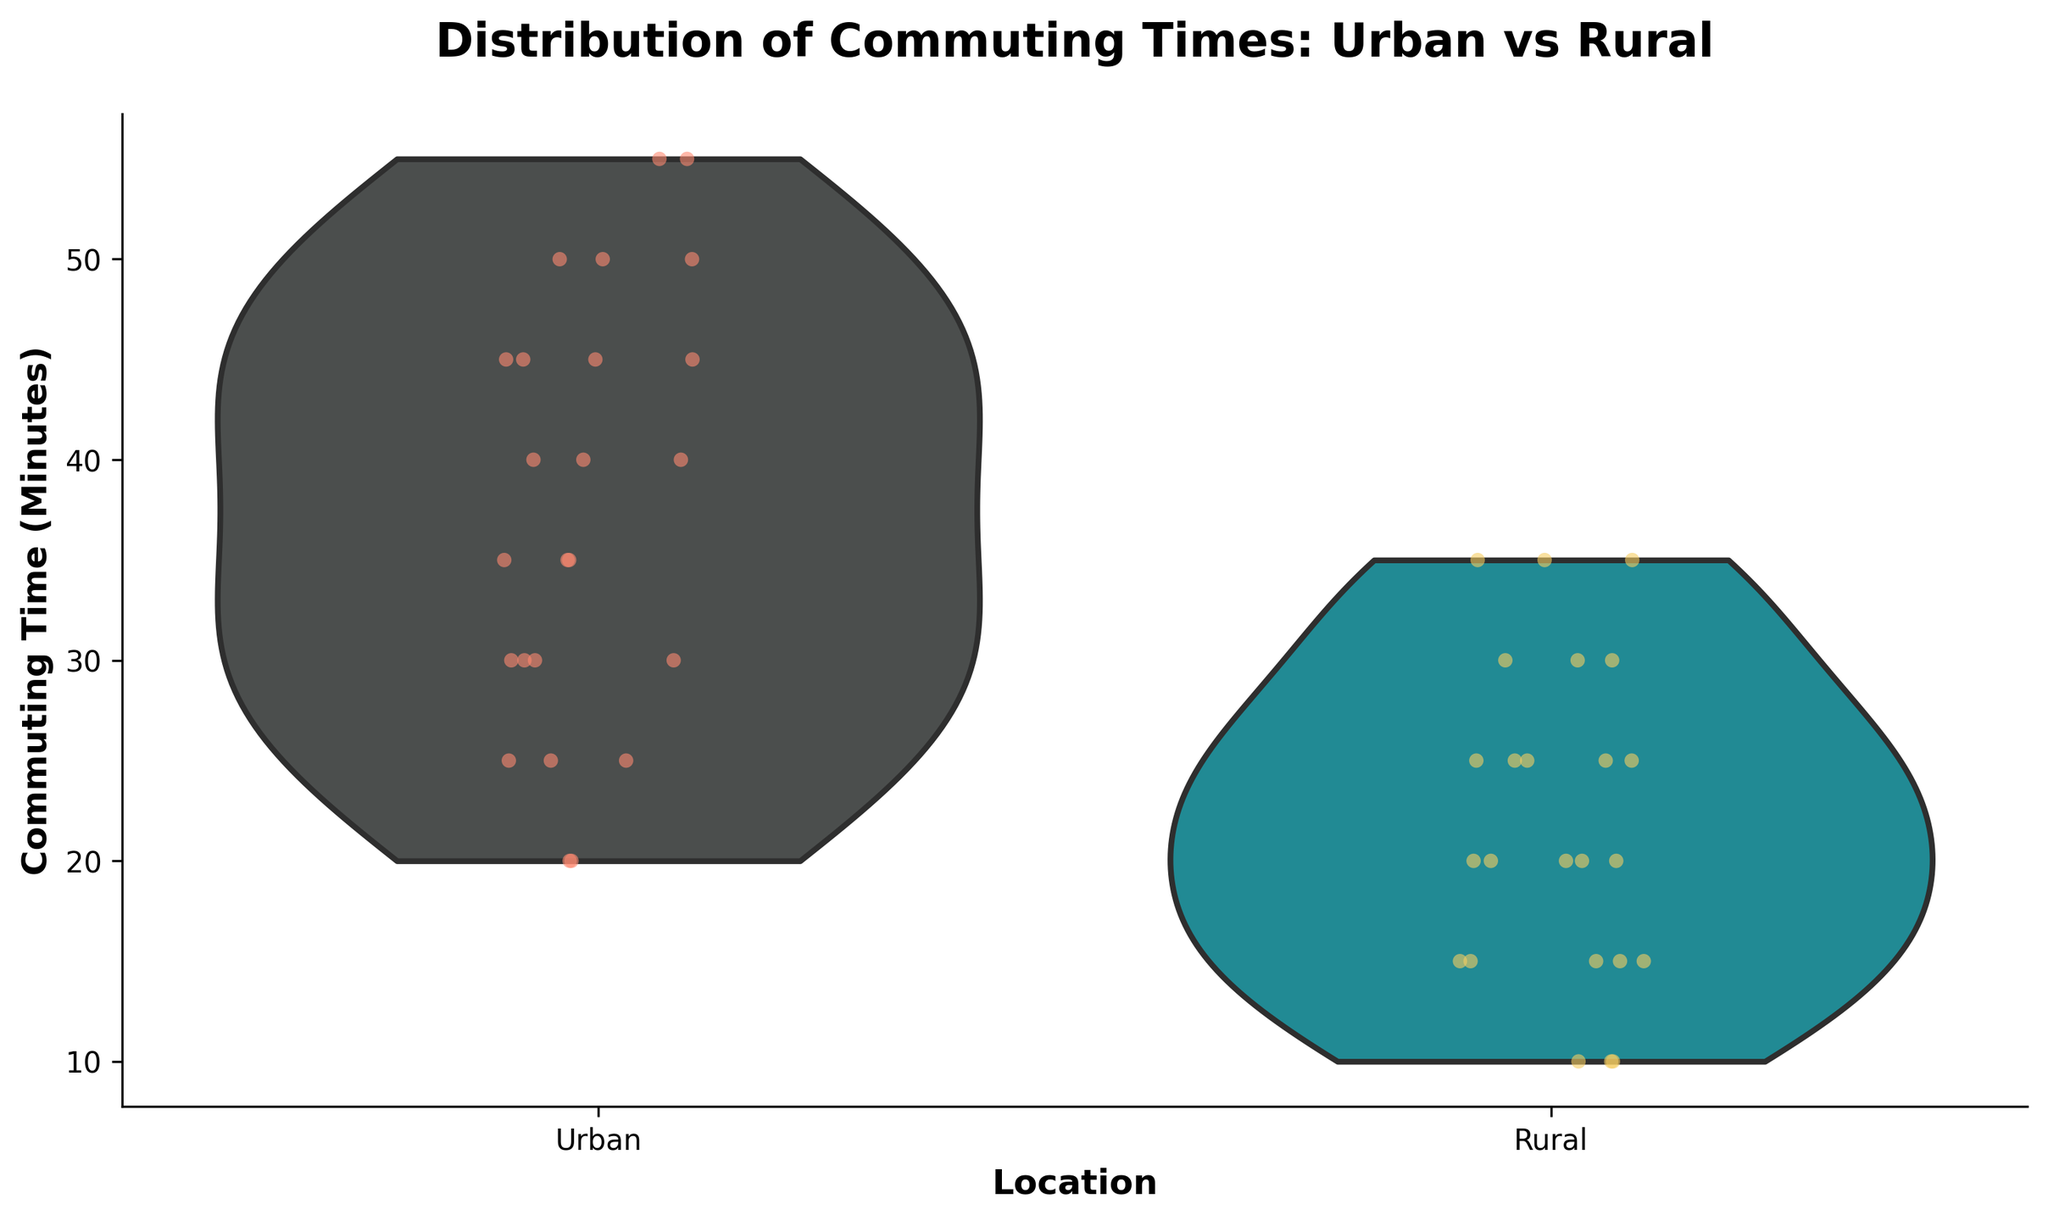What is the title of the plot? The title is located at the top of the figure and serves as an overview of the chart's topic.
Answer: Distribution of Commuting Times: Urban vs Rural What are the locations compared in the plot? The x-axis labels indicate the categories being compared.
Answer: Urban and Rural Which location shows a wider range of commuting times? By examining the spread of the violin plot for each category, you can determine the one with a broader spread. The Urban area shows a much wider range from around 20 to 55 minutes, while the Rural area is more condensed.
Answer: Urban Which location has the higher median commuting time? The median is generally represented by the thicker part of the violin plot at its horizontal midpoint. The Urban plot's thicker section is higher up compared to the Rural one.
Answer: Urban How does the variability in commuting times compare between Urban and Rural areas? Observing the shape of the violin plots provides insight into the distribution. The Urban area has a much wider distribution, showing more variability than the Rural area, which seems more condensed.
Answer: Urban has more variability What can be inferred about the most common commuting times in Rural areas? The density of the violin plot and the distribution of markers provide insight. The Rural area shows a higher density around 15 to 25 minutes, indicating these are the most common commuting times.
Answer: 15 to 25 minutes Which location has more extreme values for commuting times? Determining the outliers involves looking at the ends of the violin plots. The Urban area stretches beyond 50 minutes frequently, indicating more extreme values.
Answer: Urban What is the approximate mid-range of commuting times in Urban areas? The mid-range is the average of the minimum and maximum values. From the plot, Urban ranges from 20 to 55 minutes. Thus, (20 + 55) / 2 equals 37.5.
Answer: 37.5 In which area is commuting time more homogeneous? Homogeneity can be inferred from how tightly clustered the data points are. The Rural area is more homogeneous with most points clustering around the middle of the range.
Answer: Rural 